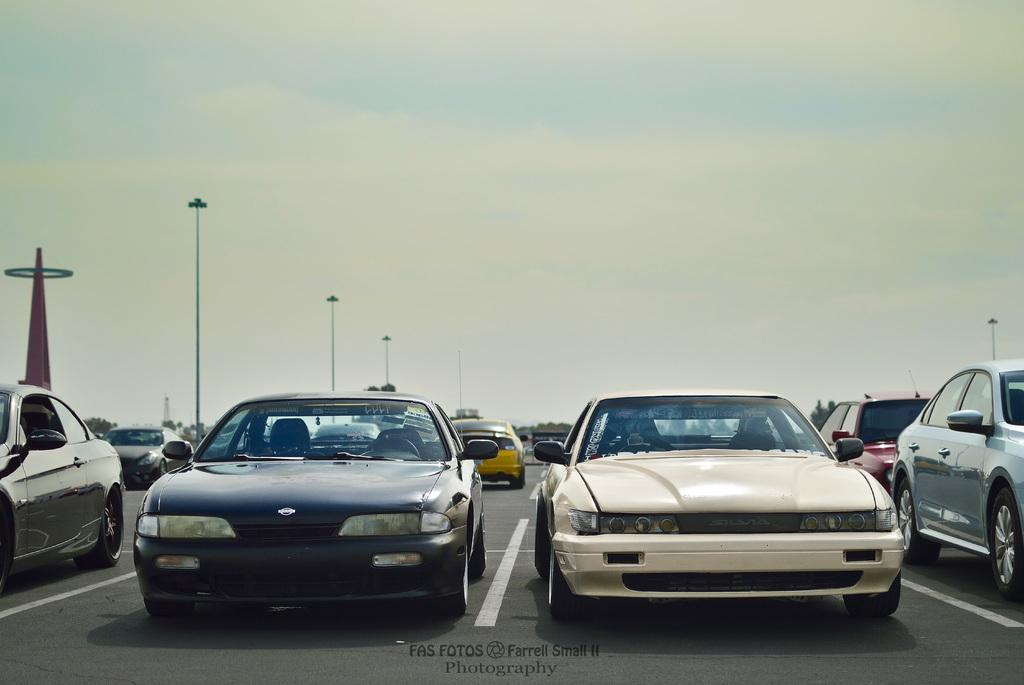What type of vehicles can be seen on the road in the image? There are cars on the road in the image. What tall structure is visible in the image? There is a tower in the image. What are the tall poles with lights on top used for in the image? Street light poles are present in the image. What type of vegetation can be seen in the image? There are trees in the image. What can be seen in the background of the image? The sky with clouds is visible in the background of the image. What type of yak can be seen grazing near the tower in the image? There is no yak present in the image; it features cars on the road, a tower, street light poles, trees, and a sky with clouds. What month is it in the image? The month cannot be determined from the image, as it does not provide any information about the time of year. 